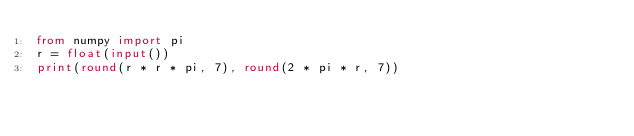Convert code to text. <code><loc_0><loc_0><loc_500><loc_500><_Python_>from numpy import pi
r = float(input())
print(round(r * r * pi, 7), round(2 * pi * r, 7))</code> 